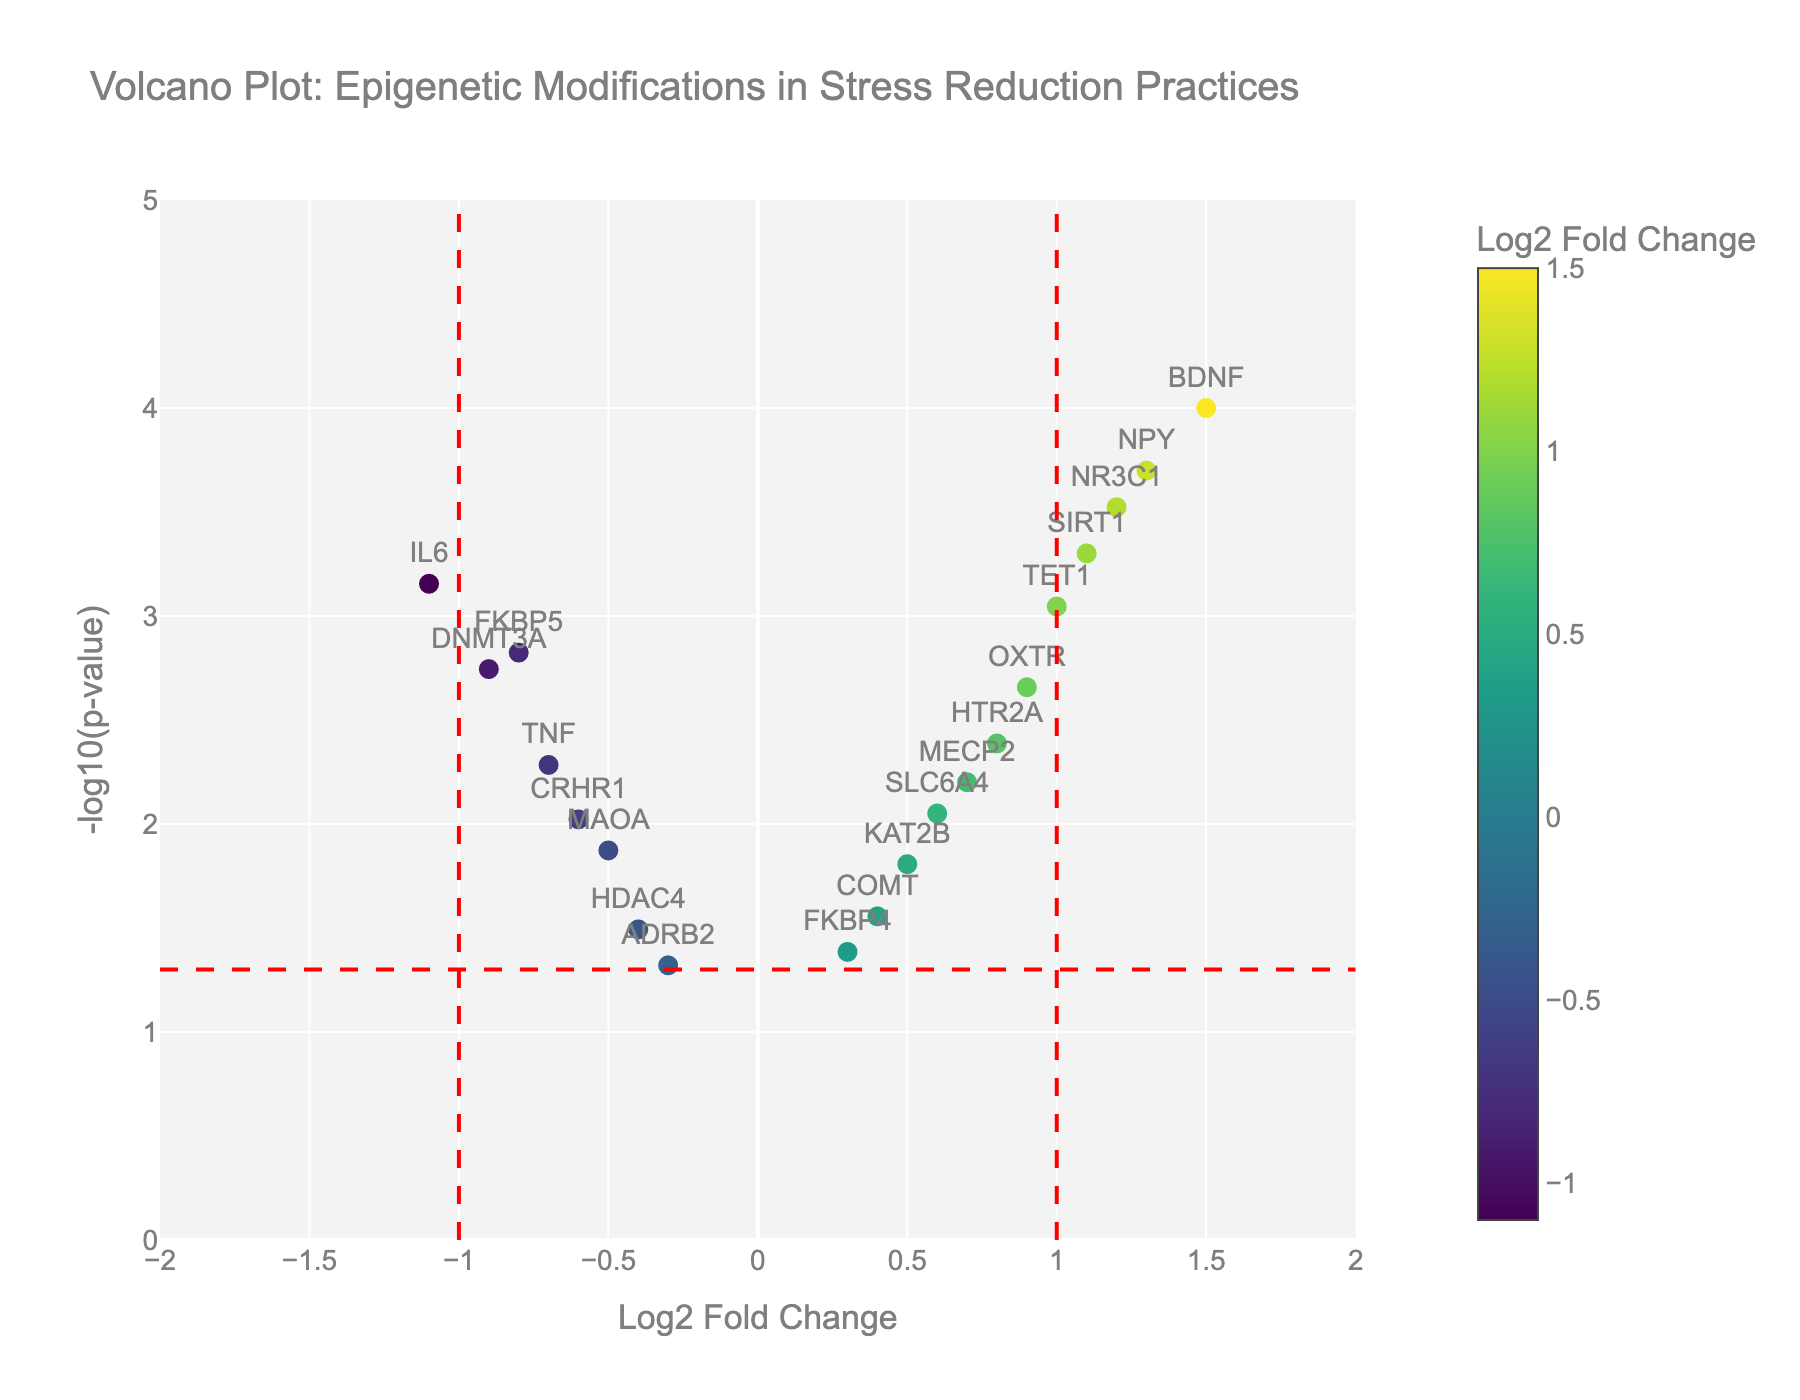What's the title of this plot? The title is usually shown at the top of the plot to summarize the main subject of the data visualization. In this case, the title is "Volcano Plot: Epigenetic Modifications in Stress Reduction Practices."
Answer: Volcano Plot: Epigenetic Modifications in Stress Reduction Practices What are the x-axis and y-axis titles? The axes titles are provided along the axes themselves to indicate what each axis represents. The x-axis title is "Log2 Fold Change" and the y-axis title is "-log10(p-value).”
Answer: Log2 Fold Change, -log10(p-value) How many genes have a Log2 Fold Change greater than 1? To determine this, examine the x-axis values and count the number of data points that lie to the right of the vertical red line at Log2 Fold Change = 1. This represents genes with fold change values greater than 1.
Answer: 4 Which gene shows the most significant change in terms of p-value? To find the most significant p-value, look for the data point that is highest on the y-axis, as higher positions represent lower p-values (since they are -log10 transformed). The gene NPY is highest with a -log10(p-value) around 3.7.
Answer: NPY Are there more genes with positive or negative Log2 Fold Change? Count the number of data points on each side of the vertical line at Log2 Fold Change = 0. There are more points on the right side (positive values) than on the left side (negative values).
Answer: More genes with positive Log2 Fold Change Which gene has the highest Log2 Fold Change? To find the gene with the highest Log2 Fold Change, identify the data point that is furthest to the right on the x-axis. The gene BDNF has the highest Log2 Fold Change at 1.5.
Answer: BDNF What is the significance threshold for the p-value, and how many genes exceed it? The significance threshold for p-value is usually set at 0.05. In the plot, this threshold corresponds to -log10(p-value) = 1.3 (as -log10(0.05) ≈ 1.3). Count the data points above the horizontal red line at y = 1.3.
Answer: 12 genes Which genes have both a Log2 Fold Change > 0.5 and a p-value < 0.01? First, identify the data points with x-axis values (Log2 Fold Change) greater than 0.5. Then ensure they are above a y-axis value (-log10(p-value)) corresponding to a p-value less than 0.01. The genes that satisfy these conditions are BDNF, NR3C1, NPY, OXTR, and TET1.
Answer: BDNF, NR3C1, NPY, OXTR, TET1 Is there any gene with a Log2 Fold Change < -1? Check for any data points that lie to the left of the vertical red line at Log2 Fold Change = -1. The gene IL6 meets this criterion with a Log2 Fold Change of -1.1.
Answer: IL6 